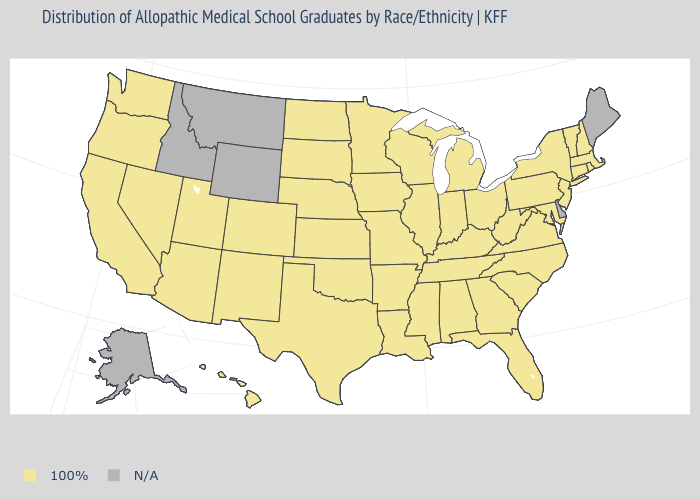Name the states that have a value in the range 100%?
Short answer required. Alabama, Arizona, Arkansas, California, Colorado, Connecticut, Florida, Georgia, Hawaii, Illinois, Indiana, Iowa, Kansas, Kentucky, Louisiana, Maryland, Massachusetts, Michigan, Minnesota, Mississippi, Missouri, Nebraska, Nevada, New Hampshire, New Jersey, New Mexico, New York, North Carolina, North Dakota, Ohio, Oklahoma, Oregon, Pennsylvania, Rhode Island, South Carolina, South Dakota, Tennessee, Texas, Utah, Vermont, Virginia, Washington, West Virginia, Wisconsin. What is the value of New Mexico?
Write a very short answer. 100%. Name the states that have a value in the range 100%?
Concise answer only. Alabama, Arizona, Arkansas, California, Colorado, Connecticut, Florida, Georgia, Hawaii, Illinois, Indiana, Iowa, Kansas, Kentucky, Louisiana, Maryland, Massachusetts, Michigan, Minnesota, Mississippi, Missouri, Nebraska, Nevada, New Hampshire, New Jersey, New Mexico, New York, North Carolina, North Dakota, Ohio, Oklahoma, Oregon, Pennsylvania, Rhode Island, South Carolina, South Dakota, Tennessee, Texas, Utah, Vermont, Virginia, Washington, West Virginia, Wisconsin. What is the lowest value in states that border Texas?
Short answer required. 100%. Which states have the lowest value in the South?
Concise answer only. Alabama, Arkansas, Florida, Georgia, Kentucky, Louisiana, Maryland, Mississippi, North Carolina, Oklahoma, South Carolina, Tennessee, Texas, Virginia, West Virginia. What is the value of Connecticut?
Short answer required. 100%. Which states hav the highest value in the MidWest?
Give a very brief answer. Illinois, Indiana, Iowa, Kansas, Michigan, Minnesota, Missouri, Nebraska, North Dakota, Ohio, South Dakota, Wisconsin. Name the states that have a value in the range N/A?
Concise answer only. Alaska, Delaware, Idaho, Maine, Montana, Wyoming. What is the value of Idaho?
Answer briefly. N/A. What is the lowest value in the USA?
Write a very short answer. 100%. What is the value of Oregon?
Answer briefly. 100%. 